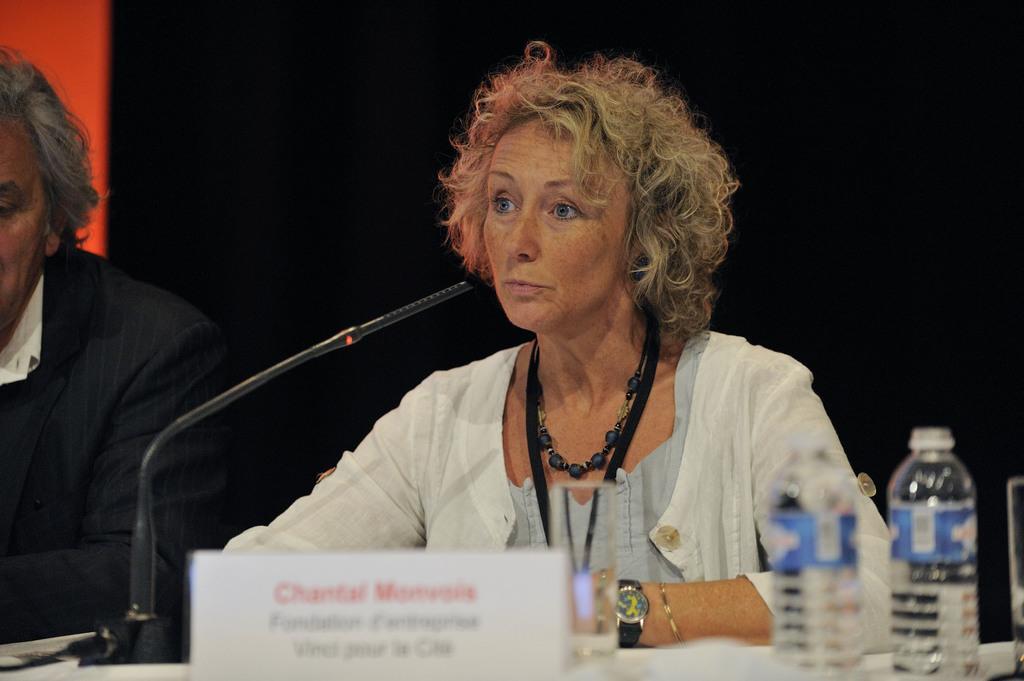Can you describe this image briefly? In this image I see a woman and a man and I see the name board over here which is blurred and I see the glass in 2 bottles and I see the black color thing over here and it is red and black in the background. 